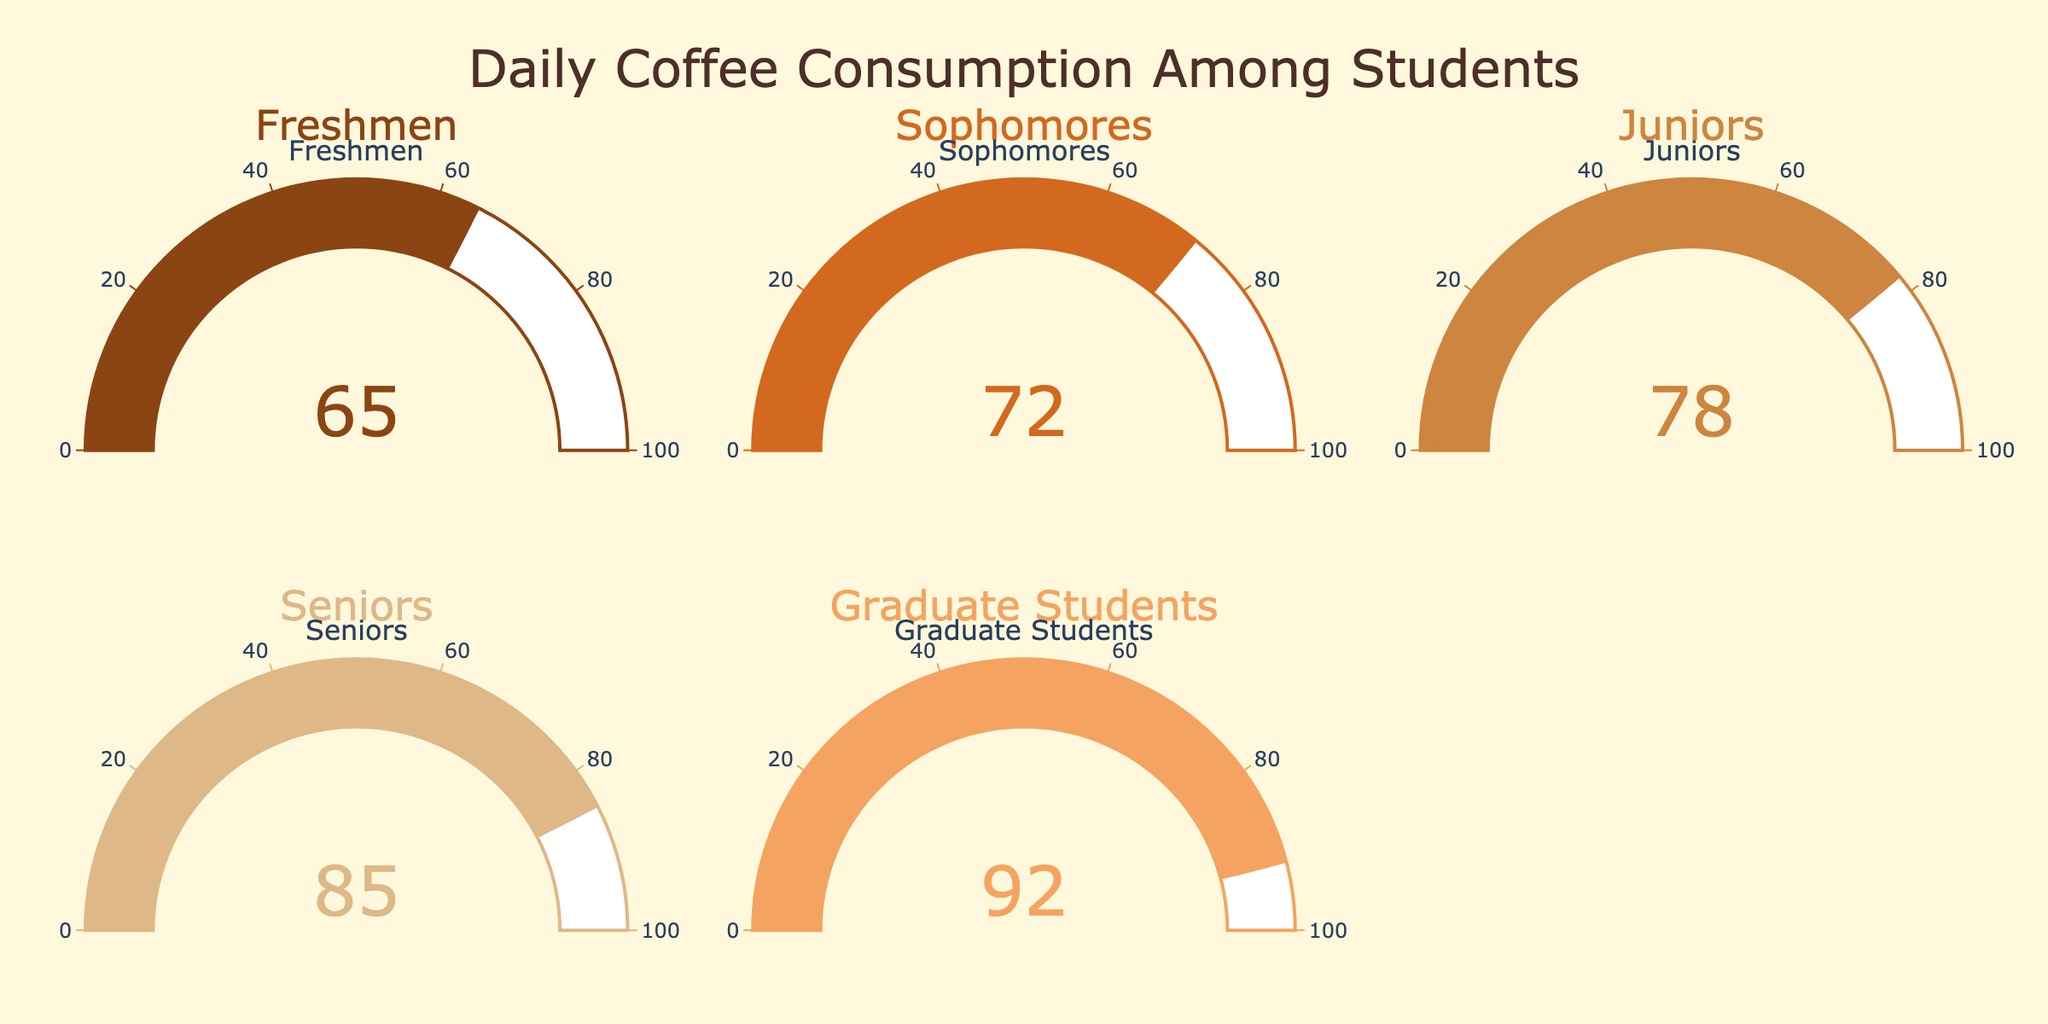what is the title of the figure? The title of the figure can be directly seen at the top of the chart. It usually describes the overall content or the main topic of the chart.
Answer: Daily Coffee Consumption Among Students Which student group has the highest coffee consumption percentage? To answer this question, look for the gauge with the highest value displayed. Each gauge represents a different student group.
Answer: Graduate Students What is the difference in coffee consumption percentage between Sophomores and Freshmen? Check the values displayed in the gauges for both Sophomores and Freshmen, then subtract the Freshmen's value from the Sophomores' value. Sophomores: 72%, Freshmen: 65%. Difference: 72% - 65%.
Answer: 7% Among the groups depicted, what is the average coffee consumption percentage? To find the average, add the values of all groups and divide by the number of groups: (65 + 72 + 78 + 85 + 92) / 5.
Answer: 78.4% Is the coffee consumption percentage of seniors closer to the value of juniors or graduate students? Find the absolute difference between seniors and juniors, and seniors and graduate students. Compare these differences: Seniors-Juniors: 85 - 78 = 7, Seniors-Graduate Students: 92 - 85 = 7. Since the differences are equal, it is equidistant.
Answer: Equidistant What is the color used for the gauge representing Juniors? Identify the color displayed on the gauge that indicates the value for Juniors.
Answer: Light Brown By how much does the value of Seniors exceed the value of Freshmen? Find the values for Seniors and Freshmen and subtract the Freshmen's value from the Seniors' value: Seniors: 85%, Freshmen: 65%. Difference: 85% - 65%.
Answer: 20% What percentage of daily coffee consumption is indicated for Sophomores? Look at the Sophomores' gauge to find the displayed value.
Answer: 72% What percentage of daily coffee consumption is indicated for Freshmen? Look at the Freshmen's gauge to find the displayed value.
Answer: 65% 